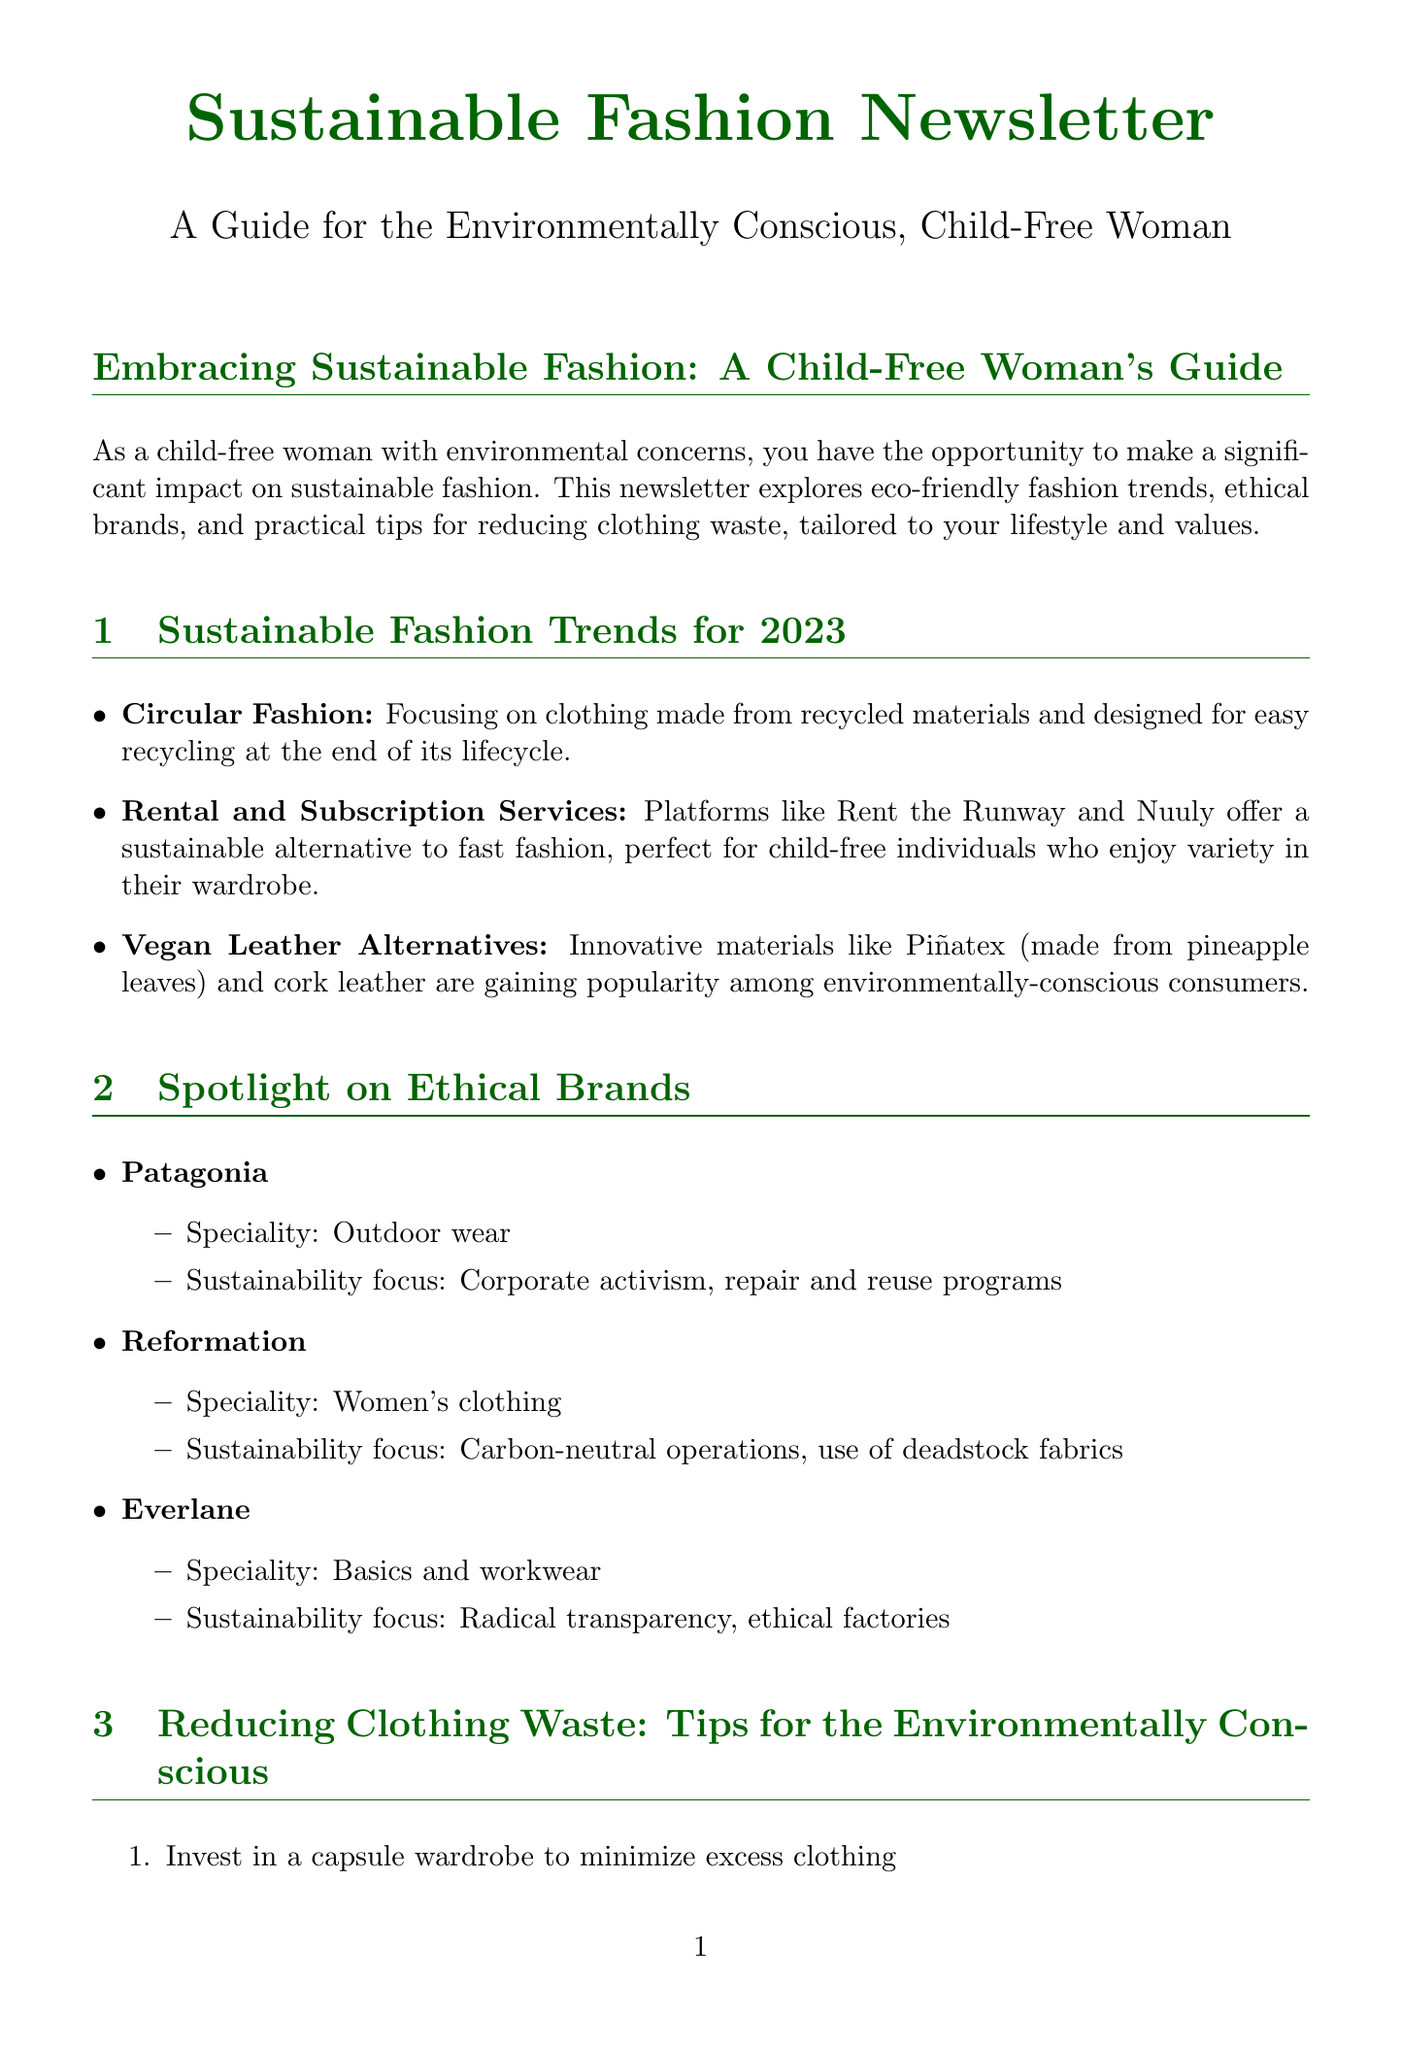What is the focus of circular fashion? The document describes circular fashion as focusing on clothing made from recycled materials and designed for easy recycling at the end of its lifecycle.
Answer: Clothing made from recycled materials Name one platform offering rental and subscription services. The document lists Rent the Runway and Nuuly as platforms offering rental and subscription services.
Answer: Rent the Runway Which brand specializes in outdoor wear? The document mentions Patagonia as a brand that specializes in outdoor wear.
Answer: Patagonia What is a tip for reducing clothing waste? The document provides multiple tips, one being to invest in a capsule wardrobe to minimize excess clothing.
Answer: Invest in a capsule wardrobe What event focuses on sustainability in fashion? The document names the Copenhagen Fashion Summit as the annual conference focusing on sustainability in fashion.
Answer: Copenhagen Fashion Summit How does Reformation ensure sustainability? The document states that Reformation focuses on carbon-neutral operations and the use of deadstock fabrics.
Answer: Carbon-neutral operations What DIY project involves upcycling old t-shirts? The document mentions upcycling old t-shirts into reusable shopping bags as a DIY project.
Answer: Reusable shopping bags Provide an example of a resource mentioned in the newsletter. The document refers to "Good On You," an app and website that rates brands based on their ethical and environmental impact.
Answer: Good On You What trend involves materials made from pineapple leaves? The document mentions vegan leather alternatives, specifically Piñatex, which is made from pineapple leaves.
Answer: Piñatex 